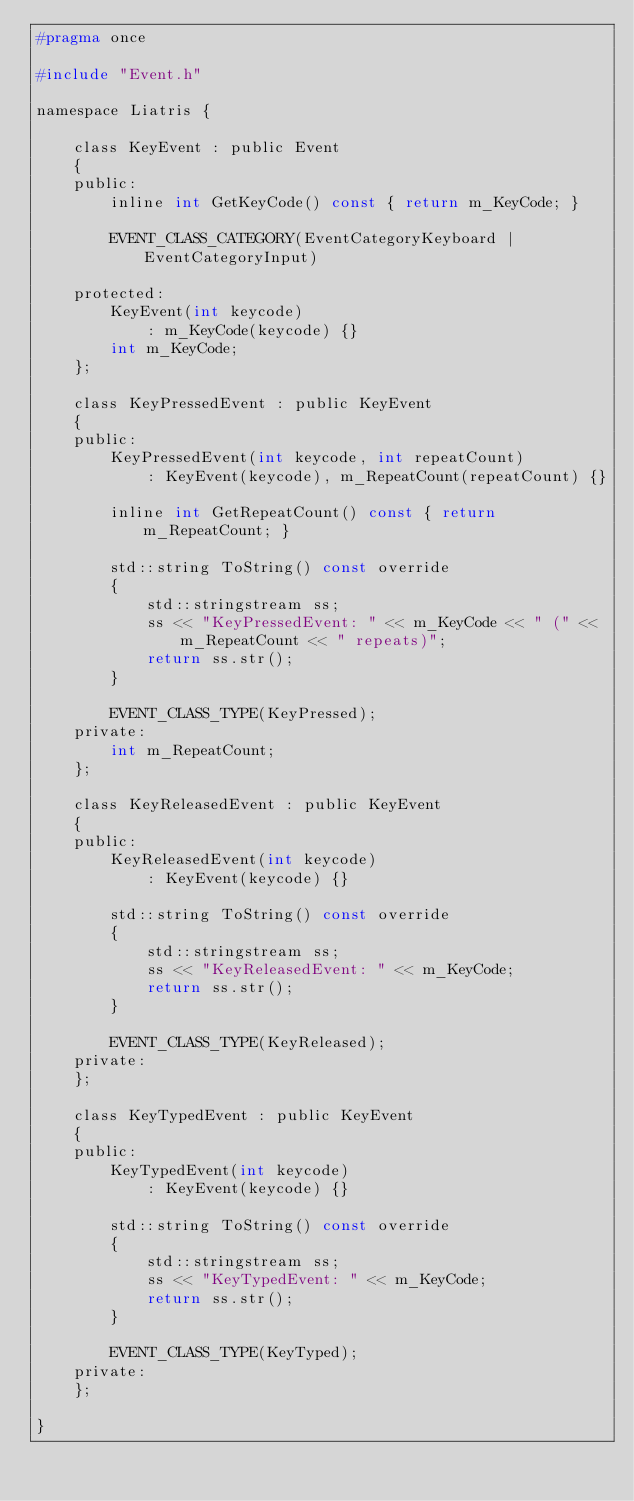Convert code to text. <code><loc_0><loc_0><loc_500><loc_500><_C_>#pragma once

#include "Event.h"

namespace Liatris {

	class KeyEvent : public Event
	{
	public:
		inline int GetKeyCode() const { return m_KeyCode; }
	
		EVENT_CLASS_CATEGORY(EventCategoryKeyboard | EventCategoryInput)

	protected:
		KeyEvent(int keycode)
			: m_KeyCode(keycode) {}
		int m_KeyCode;
	};

	class KeyPressedEvent : public KeyEvent
	{
	public:
		KeyPressedEvent(int keycode, int repeatCount)
			: KeyEvent(keycode), m_RepeatCount(repeatCount) {}

		inline int GetRepeatCount() const { return m_RepeatCount; }

		std::string ToString() const override 
		{
			std::stringstream ss;
			ss << "KeyPressedEvent: " << m_KeyCode << " (" << m_RepeatCount << " repeats)";
			return ss.str();
		}

		EVENT_CLASS_TYPE(KeyPressed);
	private:
		int m_RepeatCount;
	};

	class KeyReleasedEvent : public KeyEvent
	{
	public:
		KeyReleasedEvent(int keycode)
			: KeyEvent(keycode) {}

		std::string ToString() const override
		{
			std::stringstream ss;
			ss << "KeyReleasedEvent: " << m_KeyCode;
			return ss.str();
		}

		EVENT_CLASS_TYPE(KeyReleased);
	private:
	};

	class KeyTypedEvent : public KeyEvent
	{
	public:
		KeyTypedEvent(int keycode)
			: KeyEvent(keycode) {}

		std::string ToString() const override
		{
			std::stringstream ss;
			ss << "KeyTypedEvent: " << m_KeyCode;
			return ss.str();
		}

		EVENT_CLASS_TYPE(KeyTyped);
	private:
	};

}</code> 